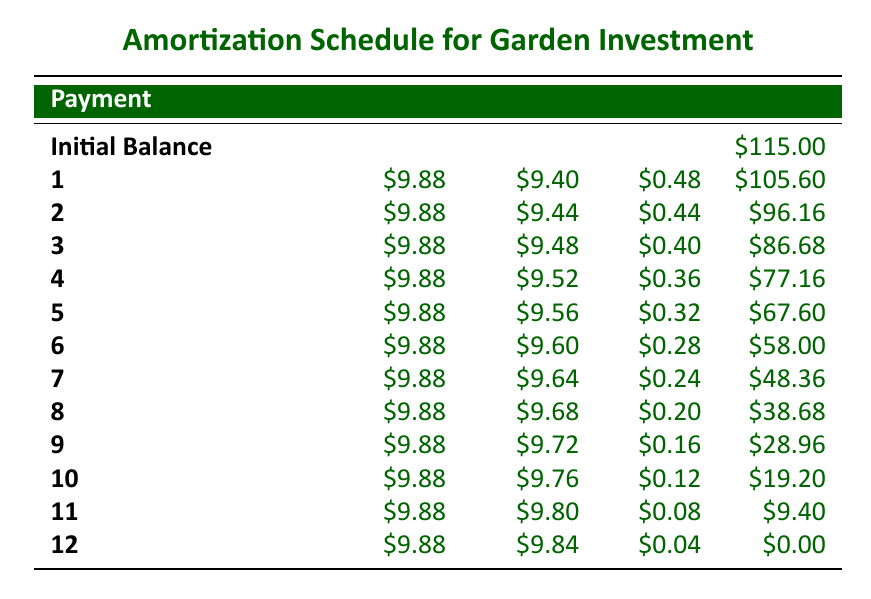What is the total amount paid by the end of the 12 months? Each payment is $9.88 and there are 12 payments, so the total amount paid is calculated as 12 * $9.88 = $118.56.
Answer: 118.56 What is the remaining balance after the 6th payment? After the 6th payment, the balance is $58.00 as indicated in the table under the Balance column for payment number 6.
Answer: 58.00 Is the principal paid in the last payment greater than the interest paid in that payment? In the last payment (payment 12), the principal is $9.84, and the interest is $0.04. Since $9.84 is greater than $0.04, the statement is true.
Answer: Yes What is the average monthly payment amount? The monthly payment amount is consistently $9.88. Therefore, the average monthly payment is also $9.88, as every month is the same.
Answer: 9.88 How much total interest is paid over the 12 months? To find the total interest paid, sum up the interest amounts for each payment, which totals $5.04 (0.48 + 0.44 + 0.40 + 0.36 + 0.32 + 0.28 + 0.24 + 0.20 + 0.16 + 0.12 + 0.08 + 0.04).
Answer: 5.04 Which month has the highest interest payment? By inspecting the interest amounts for each month, the highest interest payment is found in the first month, which is $0.48.
Answer: 1 What is the difference between the principal paid in the first payment and the principal paid in the last payment? The principal paid in the first payment is $9.40 and in the last payment is $9.84. The difference is calculated as $9.84 - $9.40 = $0.44.
Answer: 0.44 Which payment has the lowest remaining balance? The last payment, number 12, has a remaining balance of $0.00, which is the lowest possible balance.
Answer: 12 Is the total investment fully paid off by the end of the 12 months? Since the final balance at payment 12 is $0.00, this confirms that the total investment of $115.00 is fully paid off.
Answer: Yes 